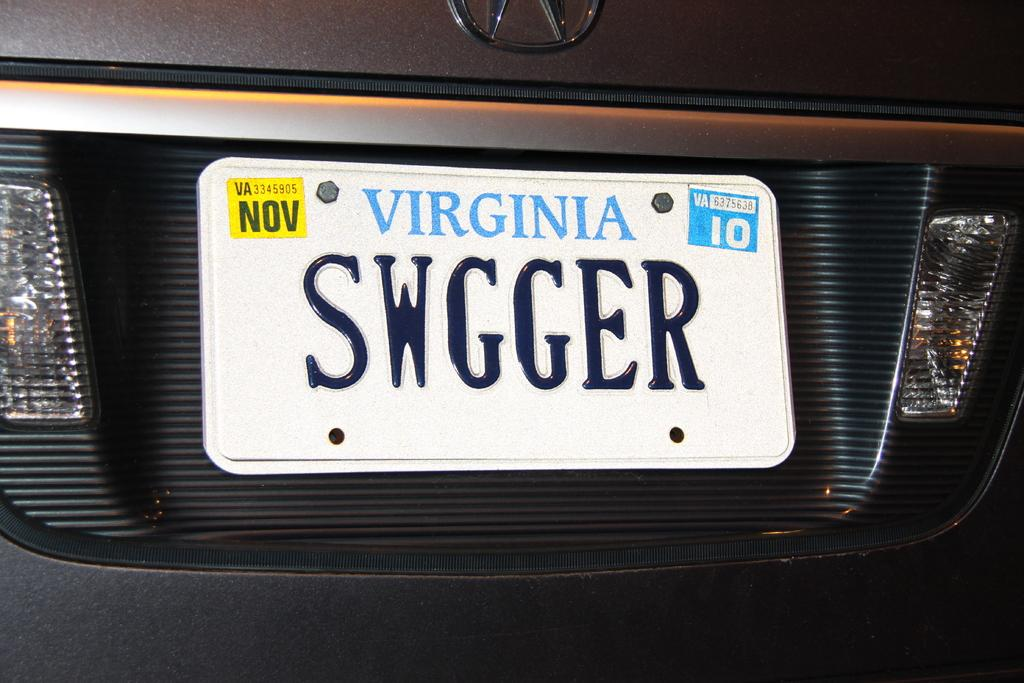<image>
Present a compact description of the photo's key features. A license plate for the state of Virginia that expires in November. 